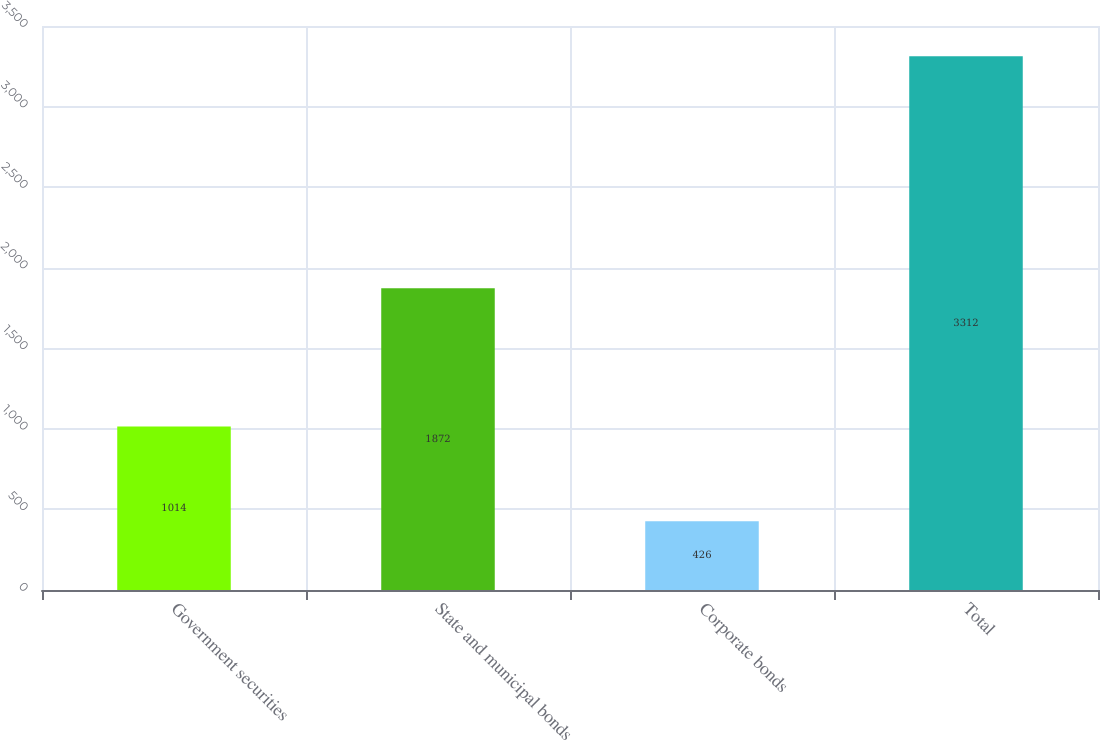<chart> <loc_0><loc_0><loc_500><loc_500><bar_chart><fcel>Government securities<fcel>State and municipal bonds<fcel>Corporate bonds<fcel>Total<nl><fcel>1014<fcel>1872<fcel>426<fcel>3312<nl></chart> 